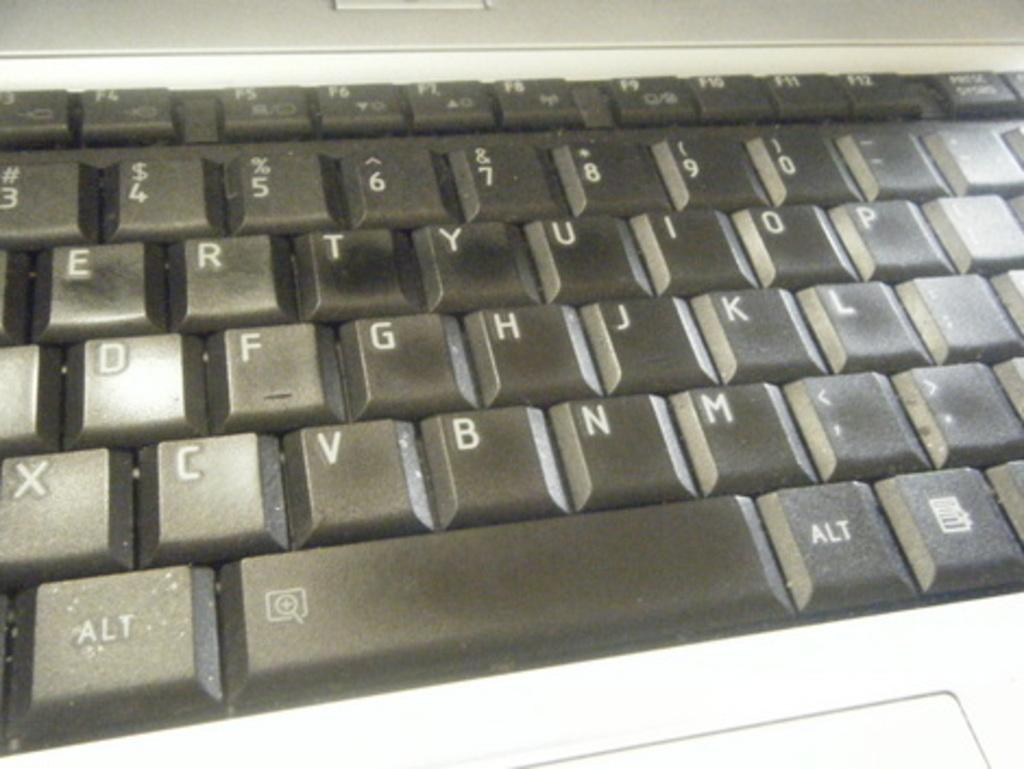<image>
Render a clear and concise summary of the photo. A black keyboard displays an ALT key next to the space bar. 